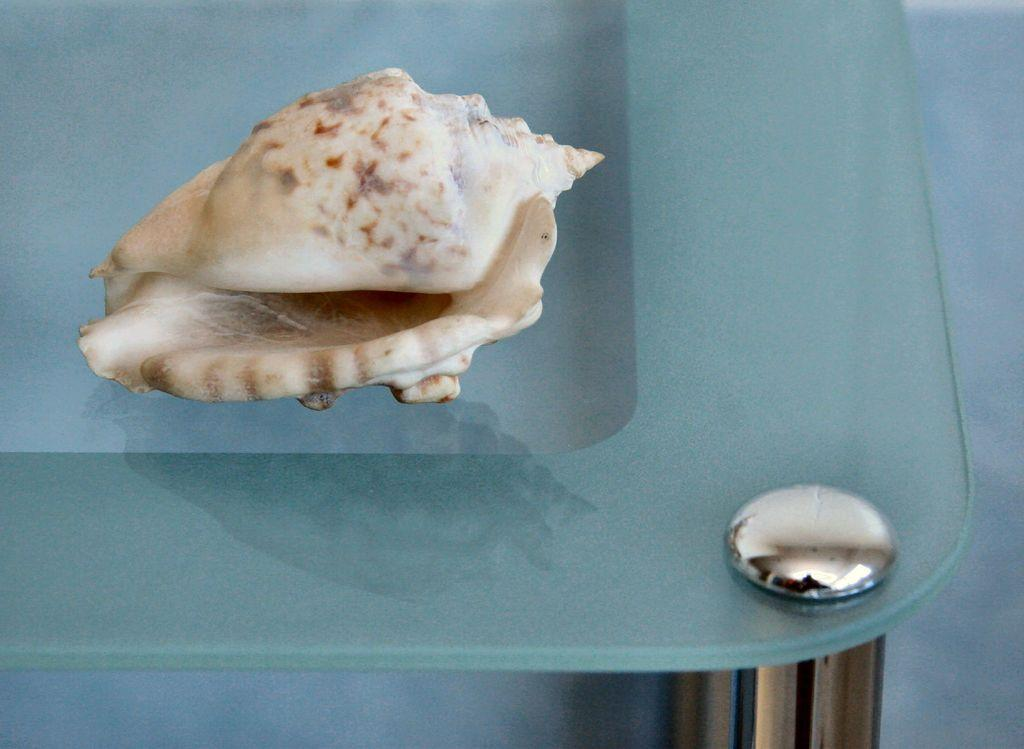What object is the main focus of the image? There is a sea shell in the image. Where is the sea shell located? The sea shell is placed on a glass table. What type of connection does the crook have with the sea shell in the image? There is no crook present in the image, so there is no connection between a crook and the sea shell. 